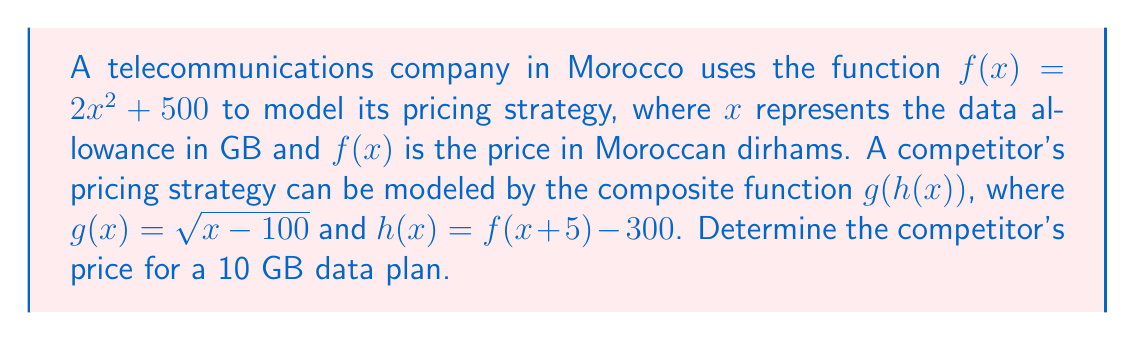Provide a solution to this math problem. To solve this problem, we'll follow these steps:

1) First, we need to find $f(x + 5)$:
   $f(x + 5) = 2(x + 5)^2 + 500$
   $= 2(x^2 + 10x + 25) + 500$
   $= 2x^2 + 20x + 50 + 500$
   $= 2x^2 + 20x + 550$

2) Now we can determine $h(x)$:
   $h(x) = f(x + 5) - 300$
   $= (2x^2 + 20x + 550) - 300$
   $= 2x^2 + 20x + 250$

3) We need to find $h(10)$ since we're looking at a 10 GB plan:
   $h(10) = 2(10)^2 + 20(10) + 250$
   $= 200 + 200 + 250$
   $= 650$

4) Finally, we apply $g$ to this result:
   $g(h(10)) = g(650)$
   $= \sqrt{650 - 100}$
   $= \sqrt{550}$
   $\approx 23.45$

Therefore, the competitor's price for a 10 GB data plan is approximately 23.45 Moroccan dirhams.
Answer: $23.45$ Moroccan dirhams 